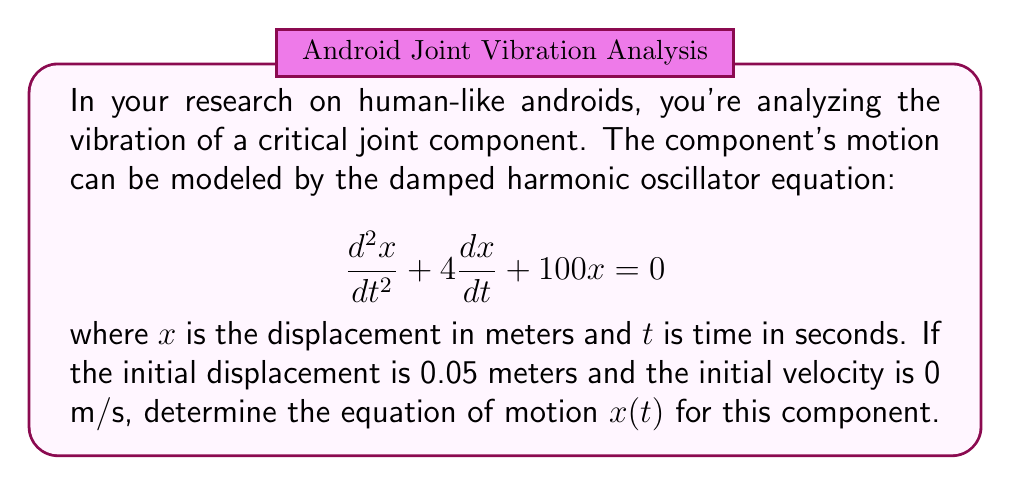Can you solve this math problem? To solve this damped harmonic oscillator equation, we'll follow these steps:

1) The general form of a damped harmonic oscillator equation is:
   $$\frac{d^2x}{dt^2} + 2\beta\frac{dx}{dt} + \omega_0^2x = 0$$
   
   Comparing this to our equation, we see that $2\beta = 4$ and $\omega_0^2 = 100$.

2) Calculate $\beta$ and $\omega_0$:
   $\beta = 2$ and $\omega_0 = 10$

3) To determine the type of damping, we calculate $\beta^2 - \omega_0^2$:
   $2^2 - 10^2 = 4 - 100 = -96 < 0$
   
   This indicates underdamped motion.

4) For underdamped motion, the general solution is:
   $$x(t) = e^{-\beta t}(A\cos(\omega t) + B\sin(\omega t))$$
   
   where $\omega = \sqrt{\omega_0^2 - \beta^2} = \sqrt{100 - 4} = \sqrt{96} = 4\sqrt{6}$

5) We need to find A and B using the initial conditions:
   $x(0) = 0.05$ and $x'(0) = 0$

6) From $x(0) = 0.05$:
   $0.05 = A$

7) From $x'(0) = 0$:
   $0 = -2A + 4\sqrt{6}B$
   $B = \frac{A}{\sqrt{6}} = \frac{0.05}{\sqrt{6}}$

8) Substituting these values into the general solution:

   $$x(t) = e^{-2t}(0.05\cos(4\sqrt{6}t) + \frac{0.05}{\sqrt{6}}\sin(4\sqrt{6}t))$$

This is the equation of motion for the component.
Answer: $$x(t) = 0.05e^{-2t}(\cos(4\sqrt{6}t) + \frac{1}{\sqrt{6}}\sin(4\sqrt{6}t))$$ 